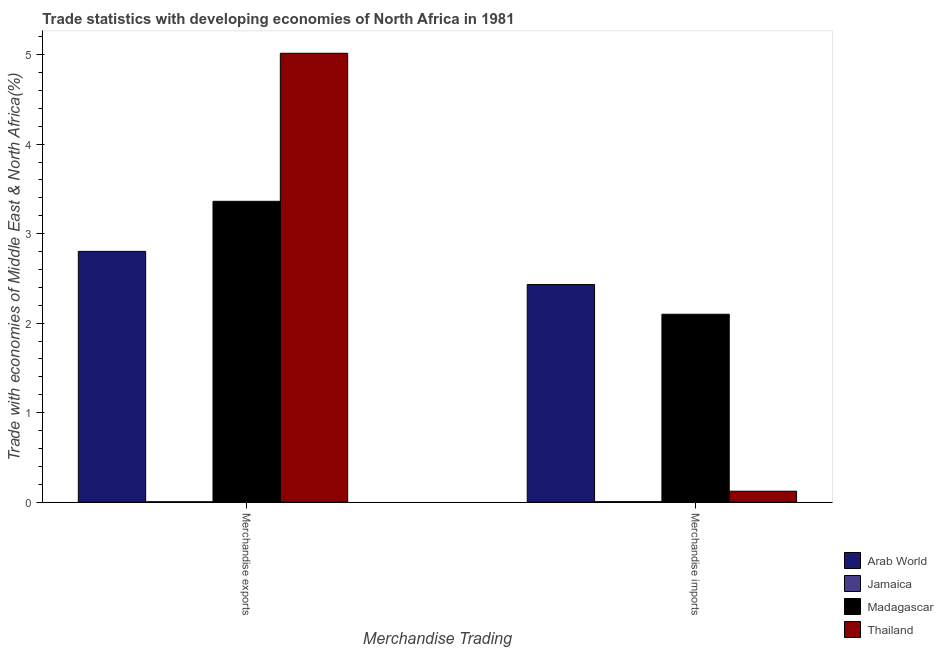How many different coloured bars are there?
Your answer should be very brief. 4. How many bars are there on the 1st tick from the left?
Provide a short and direct response. 4. How many bars are there on the 1st tick from the right?
Your answer should be very brief. 4. What is the label of the 1st group of bars from the left?
Your answer should be compact. Merchandise exports. What is the merchandise exports in Thailand?
Make the answer very short. 5.02. Across all countries, what is the maximum merchandise imports?
Your response must be concise. 2.43. Across all countries, what is the minimum merchandise imports?
Your answer should be very brief. 0.01. In which country was the merchandise imports maximum?
Offer a terse response. Arab World. In which country was the merchandise imports minimum?
Offer a very short reply. Jamaica. What is the total merchandise exports in the graph?
Your response must be concise. 11.18. What is the difference between the merchandise exports in Thailand and that in Arab World?
Make the answer very short. 2.21. What is the difference between the merchandise exports in Arab World and the merchandise imports in Jamaica?
Your answer should be compact. 2.8. What is the average merchandise exports per country?
Provide a succinct answer. 2.8. What is the difference between the merchandise imports and merchandise exports in Arab World?
Offer a terse response. -0.37. What is the ratio of the merchandise imports in Thailand to that in Jamaica?
Ensure brevity in your answer.  23.34. In how many countries, is the merchandise exports greater than the average merchandise exports taken over all countries?
Offer a terse response. 3. What does the 2nd bar from the left in Merchandise imports represents?
Provide a short and direct response. Jamaica. What does the 4th bar from the right in Merchandise exports represents?
Your answer should be very brief. Arab World. Are all the bars in the graph horizontal?
Ensure brevity in your answer.  No. How many countries are there in the graph?
Your answer should be compact. 4. What is the difference between two consecutive major ticks on the Y-axis?
Offer a terse response. 1. Are the values on the major ticks of Y-axis written in scientific E-notation?
Make the answer very short. No. Where does the legend appear in the graph?
Give a very brief answer. Bottom right. How many legend labels are there?
Give a very brief answer. 4. How are the legend labels stacked?
Offer a terse response. Vertical. What is the title of the graph?
Keep it short and to the point. Trade statistics with developing economies of North Africa in 1981. Does "Argentina" appear as one of the legend labels in the graph?
Keep it short and to the point. No. What is the label or title of the X-axis?
Offer a very short reply. Merchandise Trading. What is the label or title of the Y-axis?
Your response must be concise. Trade with economies of Middle East & North Africa(%). What is the Trade with economies of Middle East & North Africa(%) of Arab World in Merchandise exports?
Offer a terse response. 2.8. What is the Trade with economies of Middle East & North Africa(%) of Jamaica in Merchandise exports?
Make the answer very short. 0. What is the Trade with economies of Middle East & North Africa(%) of Madagascar in Merchandise exports?
Keep it short and to the point. 3.36. What is the Trade with economies of Middle East & North Africa(%) in Thailand in Merchandise exports?
Offer a very short reply. 5.02. What is the Trade with economies of Middle East & North Africa(%) in Arab World in Merchandise imports?
Your answer should be very brief. 2.43. What is the Trade with economies of Middle East & North Africa(%) of Jamaica in Merchandise imports?
Your answer should be compact. 0.01. What is the Trade with economies of Middle East & North Africa(%) of Madagascar in Merchandise imports?
Make the answer very short. 2.1. What is the Trade with economies of Middle East & North Africa(%) of Thailand in Merchandise imports?
Ensure brevity in your answer.  0.12. Across all Merchandise Trading, what is the maximum Trade with economies of Middle East & North Africa(%) of Arab World?
Provide a succinct answer. 2.8. Across all Merchandise Trading, what is the maximum Trade with economies of Middle East & North Africa(%) of Jamaica?
Make the answer very short. 0.01. Across all Merchandise Trading, what is the maximum Trade with economies of Middle East & North Africa(%) in Madagascar?
Offer a very short reply. 3.36. Across all Merchandise Trading, what is the maximum Trade with economies of Middle East & North Africa(%) of Thailand?
Provide a succinct answer. 5.02. Across all Merchandise Trading, what is the minimum Trade with economies of Middle East & North Africa(%) of Arab World?
Your answer should be compact. 2.43. Across all Merchandise Trading, what is the minimum Trade with economies of Middle East & North Africa(%) of Jamaica?
Provide a short and direct response. 0. Across all Merchandise Trading, what is the minimum Trade with economies of Middle East & North Africa(%) of Madagascar?
Your response must be concise. 2.1. Across all Merchandise Trading, what is the minimum Trade with economies of Middle East & North Africa(%) of Thailand?
Ensure brevity in your answer.  0.12. What is the total Trade with economies of Middle East & North Africa(%) of Arab World in the graph?
Keep it short and to the point. 5.23. What is the total Trade with economies of Middle East & North Africa(%) in Jamaica in the graph?
Provide a short and direct response. 0.01. What is the total Trade with economies of Middle East & North Africa(%) of Madagascar in the graph?
Ensure brevity in your answer.  5.46. What is the total Trade with economies of Middle East & North Africa(%) of Thailand in the graph?
Your answer should be compact. 5.14. What is the difference between the Trade with economies of Middle East & North Africa(%) in Arab World in Merchandise exports and that in Merchandise imports?
Provide a short and direct response. 0.37. What is the difference between the Trade with economies of Middle East & North Africa(%) of Jamaica in Merchandise exports and that in Merchandise imports?
Your response must be concise. -0. What is the difference between the Trade with economies of Middle East & North Africa(%) in Madagascar in Merchandise exports and that in Merchandise imports?
Provide a short and direct response. 1.26. What is the difference between the Trade with economies of Middle East & North Africa(%) of Thailand in Merchandise exports and that in Merchandise imports?
Offer a terse response. 4.89. What is the difference between the Trade with economies of Middle East & North Africa(%) in Arab World in Merchandise exports and the Trade with economies of Middle East & North Africa(%) in Jamaica in Merchandise imports?
Give a very brief answer. 2.8. What is the difference between the Trade with economies of Middle East & North Africa(%) in Arab World in Merchandise exports and the Trade with economies of Middle East & North Africa(%) in Madagascar in Merchandise imports?
Give a very brief answer. 0.7. What is the difference between the Trade with economies of Middle East & North Africa(%) of Arab World in Merchandise exports and the Trade with economies of Middle East & North Africa(%) of Thailand in Merchandise imports?
Offer a very short reply. 2.68. What is the difference between the Trade with economies of Middle East & North Africa(%) of Jamaica in Merchandise exports and the Trade with economies of Middle East & North Africa(%) of Madagascar in Merchandise imports?
Keep it short and to the point. -2.1. What is the difference between the Trade with economies of Middle East & North Africa(%) in Jamaica in Merchandise exports and the Trade with economies of Middle East & North Africa(%) in Thailand in Merchandise imports?
Make the answer very short. -0.12. What is the difference between the Trade with economies of Middle East & North Africa(%) of Madagascar in Merchandise exports and the Trade with economies of Middle East & North Africa(%) of Thailand in Merchandise imports?
Ensure brevity in your answer.  3.24. What is the average Trade with economies of Middle East & North Africa(%) of Arab World per Merchandise Trading?
Give a very brief answer. 2.62. What is the average Trade with economies of Middle East & North Africa(%) in Jamaica per Merchandise Trading?
Ensure brevity in your answer.  0. What is the average Trade with economies of Middle East & North Africa(%) in Madagascar per Merchandise Trading?
Provide a succinct answer. 2.73. What is the average Trade with economies of Middle East & North Africa(%) of Thailand per Merchandise Trading?
Offer a very short reply. 2.57. What is the difference between the Trade with economies of Middle East & North Africa(%) in Arab World and Trade with economies of Middle East & North Africa(%) in Jamaica in Merchandise exports?
Your answer should be very brief. 2.8. What is the difference between the Trade with economies of Middle East & North Africa(%) in Arab World and Trade with economies of Middle East & North Africa(%) in Madagascar in Merchandise exports?
Offer a terse response. -0.56. What is the difference between the Trade with economies of Middle East & North Africa(%) of Arab World and Trade with economies of Middle East & North Africa(%) of Thailand in Merchandise exports?
Give a very brief answer. -2.21. What is the difference between the Trade with economies of Middle East & North Africa(%) of Jamaica and Trade with economies of Middle East & North Africa(%) of Madagascar in Merchandise exports?
Your response must be concise. -3.36. What is the difference between the Trade with economies of Middle East & North Africa(%) of Jamaica and Trade with economies of Middle East & North Africa(%) of Thailand in Merchandise exports?
Your response must be concise. -5.01. What is the difference between the Trade with economies of Middle East & North Africa(%) in Madagascar and Trade with economies of Middle East & North Africa(%) in Thailand in Merchandise exports?
Keep it short and to the point. -1.65. What is the difference between the Trade with economies of Middle East & North Africa(%) of Arab World and Trade with economies of Middle East & North Africa(%) of Jamaica in Merchandise imports?
Offer a terse response. 2.43. What is the difference between the Trade with economies of Middle East & North Africa(%) in Arab World and Trade with economies of Middle East & North Africa(%) in Madagascar in Merchandise imports?
Make the answer very short. 0.33. What is the difference between the Trade with economies of Middle East & North Africa(%) of Arab World and Trade with economies of Middle East & North Africa(%) of Thailand in Merchandise imports?
Provide a succinct answer. 2.31. What is the difference between the Trade with economies of Middle East & North Africa(%) in Jamaica and Trade with economies of Middle East & North Africa(%) in Madagascar in Merchandise imports?
Your answer should be very brief. -2.09. What is the difference between the Trade with economies of Middle East & North Africa(%) in Jamaica and Trade with economies of Middle East & North Africa(%) in Thailand in Merchandise imports?
Offer a very short reply. -0.12. What is the difference between the Trade with economies of Middle East & North Africa(%) of Madagascar and Trade with economies of Middle East & North Africa(%) of Thailand in Merchandise imports?
Your response must be concise. 1.98. What is the ratio of the Trade with economies of Middle East & North Africa(%) in Arab World in Merchandise exports to that in Merchandise imports?
Provide a succinct answer. 1.15. What is the ratio of the Trade with economies of Middle East & North Africa(%) of Jamaica in Merchandise exports to that in Merchandise imports?
Offer a terse response. 0.73. What is the ratio of the Trade with economies of Middle East & North Africa(%) in Madagascar in Merchandise exports to that in Merchandise imports?
Ensure brevity in your answer.  1.6. What is the ratio of the Trade with economies of Middle East & North Africa(%) in Thailand in Merchandise exports to that in Merchandise imports?
Your answer should be very brief. 41.1. What is the difference between the highest and the second highest Trade with economies of Middle East & North Africa(%) of Arab World?
Make the answer very short. 0.37. What is the difference between the highest and the second highest Trade with economies of Middle East & North Africa(%) in Jamaica?
Give a very brief answer. 0. What is the difference between the highest and the second highest Trade with economies of Middle East & North Africa(%) of Madagascar?
Provide a short and direct response. 1.26. What is the difference between the highest and the second highest Trade with economies of Middle East & North Africa(%) of Thailand?
Offer a terse response. 4.89. What is the difference between the highest and the lowest Trade with economies of Middle East & North Africa(%) of Arab World?
Your answer should be very brief. 0.37. What is the difference between the highest and the lowest Trade with economies of Middle East & North Africa(%) in Jamaica?
Your answer should be very brief. 0. What is the difference between the highest and the lowest Trade with economies of Middle East & North Africa(%) of Madagascar?
Keep it short and to the point. 1.26. What is the difference between the highest and the lowest Trade with economies of Middle East & North Africa(%) in Thailand?
Make the answer very short. 4.89. 